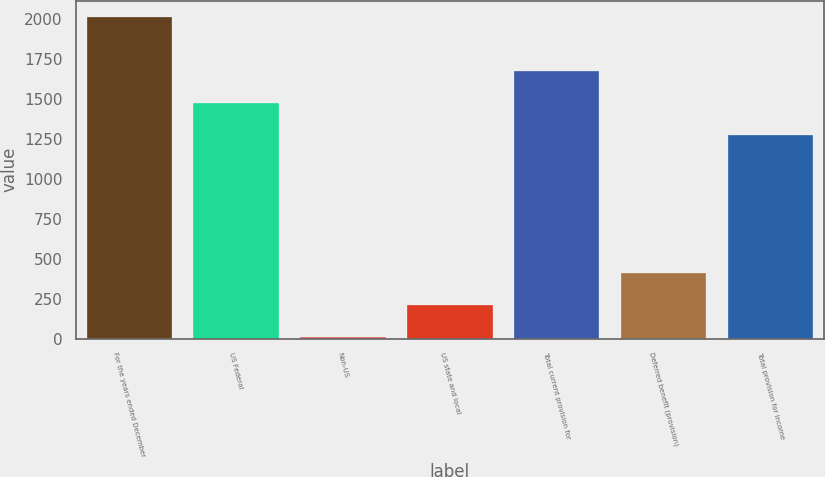<chart> <loc_0><loc_0><loc_500><loc_500><bar_chart><fcel>For the years ended December<fcel>US Federal<fcel>Non-US<fcel>US state and local<fcel>Total current provision for<fcel>Deferred benefit (provision)<fcel>Total provision for income<nl><fcel>2014<fcel>1477.7<fcel>7<fcel>207.7<fcel>1678.4<fcel>408.4<fcel>1277<nl></chart> 